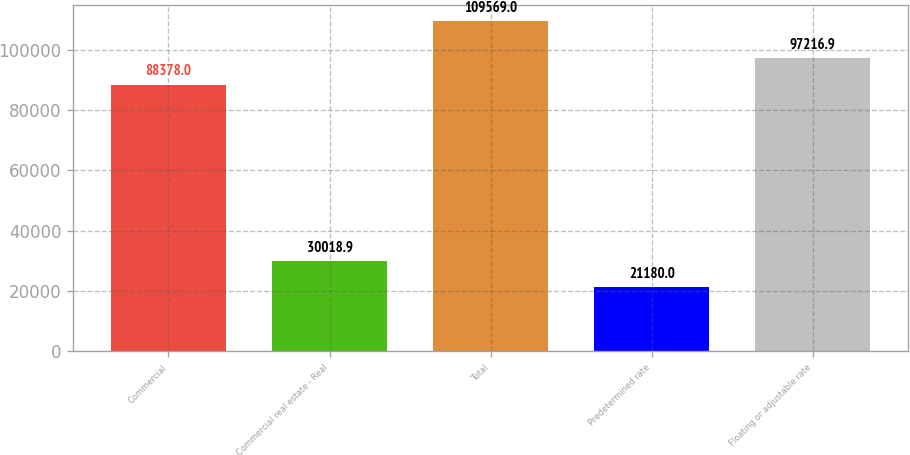Convert chart to OTSL. <chart><loc_0><loc_0><loc_500><loc_500><bar_chart><fcel>Commercial<fcel>Commercial real estate - Real<fcel>Total<fcel>Predetermined rate<fcel>Floating or adjustable rate<nl><fcel>88378<fcel>30018.9<fcel>109569<fcel>21180<fcel>97216.9<nl></chart> 